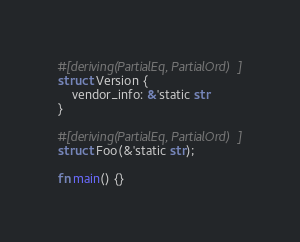Convert code to text. <code><loc_0><loc_0><loc_500><loc_500><_Rust_>#[deriving(PartialEq, PartialOrd)]
struct Version {
    vendor_info: &'static str
}

#[deriving(PartialEq, PartialOrd)]
struct Foo(&'static str);

fn main() {}
</code> 